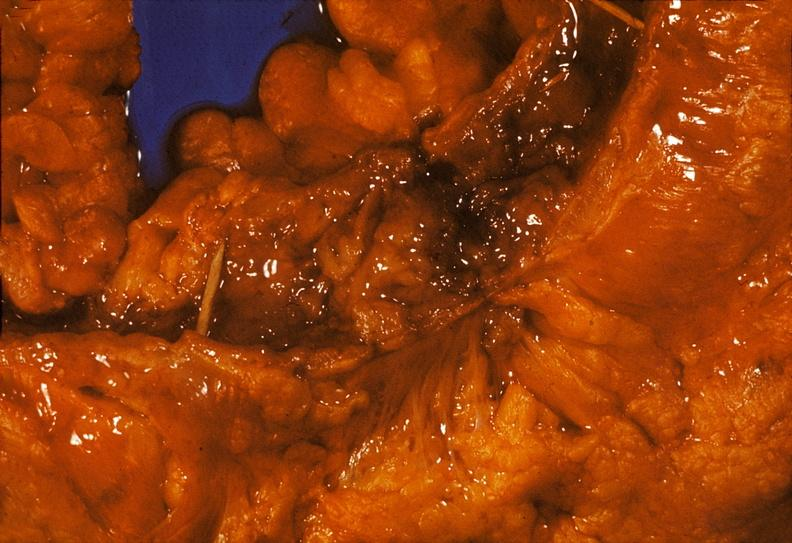s this good yellow color slide present?
Answer the question using a single word or phrase. No 